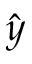<formula> <loc_0><loc_0><loc_500><loc_500>\hat { y }</formula> 